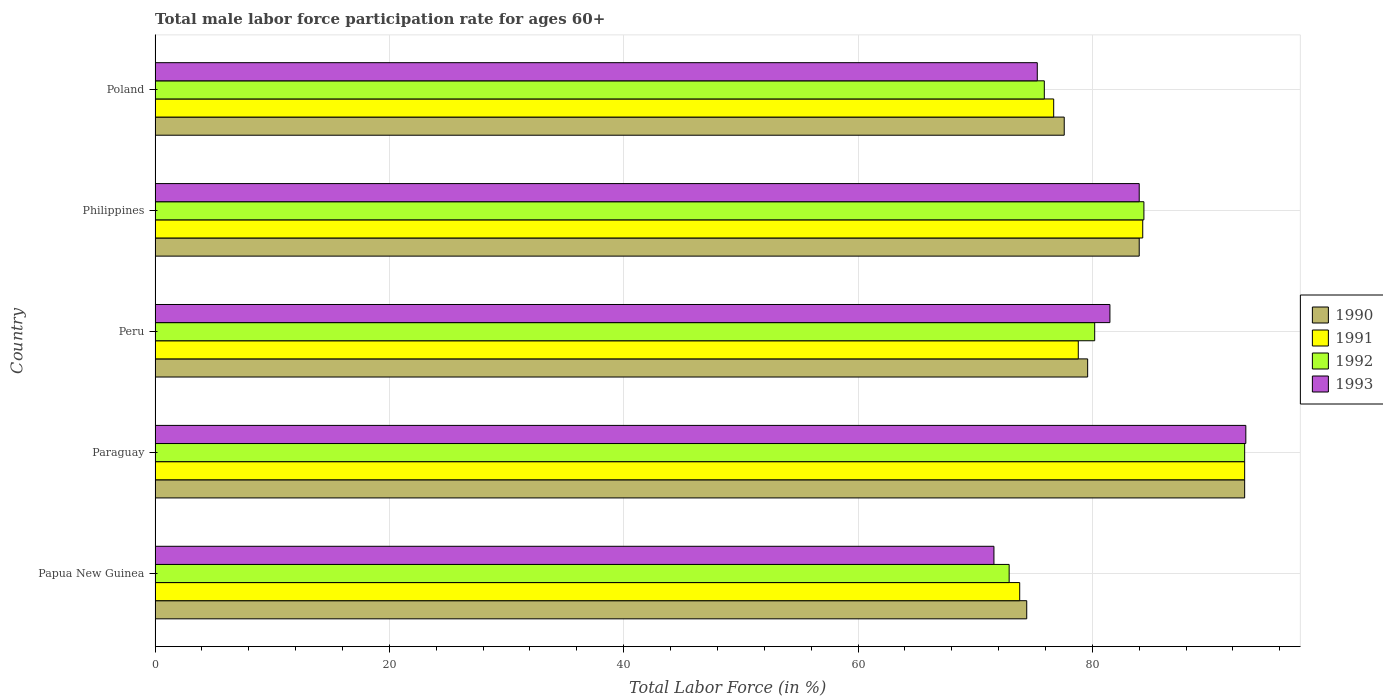How many different coloured bars are there?
Offer a very short reply. 4. Are the number of bars on each tick of the Y-axis equal?
Offer a terse response. Yes. How many bars are there on the 2nd tick from the bottom?
Offer a terse response. 4. What is the male labor force participation rate in 1990 in Philippines?
Your answer should be very brief. 84. Across all countries, what is the maximum male labor force participation rate in 1991?
Your response must be concise. 93. Across all countries, what is the minimum male labor force participation rate in 1993?
Provide a succinct answer. 71.6. In which country was the male labor force participation rate in 1990 maximum?
Your answer should be very brief. Paraguay. In which country was the male labor force participation rate in 1992 minimum?
Your response must be concise. Papua New Guinea. What is the total male labor force participation rate in 1992 in the graph?
Give a very brief answer. 406.4. What is the difference between the male labor force participation rate in 1992 in Paraguay and that in Philippines?
Your answer should be compact. 8.6. What is the difference between the male labor force participation rate in 1992 in Paraguay and the male labor force participation rate in 1990 in Philippines?
Provide a short and direct response. 9. What is the average male labor force participation rate in 1990 per country?
Offer a terse response. 81.72. What is the difference between the male labor force participation rate in 1993 and male labor force participation rate in 1992 in Philippines?
Your response must be concise. -0.4. In how many countries, is the male labor force participation rate in 1991 greater than 80 %?
Offer a very short reply. 2. What is the ratio of the male labor force participation rate in 1992 in Paraguay to that in Philippines?
Make the answer very short. 1.1. Is the male labor force participation rate in 1990 in Papua New Guinea less than that in Poland?
Keep it short and to the point. Yes. What is the difference between the highest and the lowest male labor force participation rate in 1992?
Your answer should be very brief. 20.1. Is the sum of the male labor force participation rate in 1991 in Philippines and Poland greater than the maximum male labor force participation rate in 1993 across all countries?
Offer a very short reply. Yes. Is it the case that in every country, the sum of the male labor force participation rate in 1991 and male labor force participation rate in 1992 is greater than the sum of male labor force participation rate in 1993 and male labor force participation rate in 1990?
Ensure brevity in your answer.  No. What does the 4th bar from the top in Philippines represents?
Offer a terse response. 1990. What does the 4th bar from the bottom in Poland represents?
Offer a terse response. 1993. Is it the case that in every country, the sum of the male labor force participation rate in 1992 and male labor force participation rate in 1990 is greater than the male labor force participation rate in 1991?
Ensure brevity in your answer.  Yes. What is the difference between two consecutive major ticks on the X-axis?
Provide a short and direct response. 20. Does the graph contain grids?
Make the answer very short. Yes. How many legend labels are there?
Ensure brevity in your answer.  4. How are the legend labels stacked?
Your response must be concise. Vertical. What is the title of the graph?
Provide a short and direct response. Total male labor force participation rate for ages 60+. Does "1995" appear as one of the legend labels in the graph?
Provide a short and direct response. No. What is the label or title of the X-axis?
Your answer should be very brief. Total Labor Force (in %). What is the Total Labor Force (in %) in 1990 in Papua New Guinea?
Offer a terse response. 74.4. What is the Total Labor Force (in %) of 1991 in Papua New Guinea?
Your response must be concise. 73.8. What is the Total Labor Force (in %) in 1992 in Papua New Guinea?
Your response must be concise. 72.9. What is the Total Labor Force (in %) in 1993 in Papua New Guinea?
Provide a short and direct response. 71.6. What is the Total Labor Force (in %) of 1990 in Paraguay?
Your answer should be compact. 93. What is the Total Labor Force (in %) in 1991 in Paraguay?
Ensure brevity in your answer.  93. What is the Total Labor Force (in %) in 1992 in Paraguay?
Give a very brief answer. 93. What is the Total Labor Force (in %) in 1993 in Paraguay?
Your answer should be compact. 93.1. What is the Total Labor Force (in %) of 1990 in Peru?
Keep it short and to the point. 79.6. What is the Total Labor Force (in %) of 1991 in Peru?
Keep it short and to the point. 78.8. What is the Total Labor Force (in %) in 1992 in Peru?
Ensure brevity in your answer.  80.2. What is the Total Labor Force (in %) of 1993 in Peru?
Provide a short and direct response. 81.5. What is the Total Labor Force (in %) in 1991 in Philippines?
Keep it short and to the point. 84.3. What is the Total Labor Force (in %) of 1992 in Philippines?
Provide a short and direct response. 84.4. What is the Total Labor Force (in %) in 1993 in Philippines?
Ensure brevity in your answer.  84. What is the Total Labor Force (in %) in 1990 in Poland?
Provide a short and direct response. 77.6. What is the Total Labor Force (in %) in 1991 in Poland?
Provide a succinct answer. 76.7. What is the Total Labor Force (in %) in 1992 in Poland?
Give a very brief answer. 75.9. What is the Total Labor Force (in %) of 1993 in Poland?
Provide a short and direct response. 75.3. Across all countries, what is the maximum Total Labor Force (in %) of 1990?
Keep it short and to the point. 93. Across all countries, what is the maximum Total Labor Force (in %) of 1991?
Your answer should be compact. 93. Across all countries, what is the maximum Total Labor Force (in %) of 1992?
Your answer should be compact. 93. Across all countries, what is the maximum Total Labor Force (in %) in 1993?
Provide a succinct answer. 93.1. Across all countries, what is the minimum Total Labor Force (in %) of 1990?
Your answer should be very brief. 74.4. Across all countries, what is the minimum Total Labor Force (in %) of 1991?
Give a very brief answer. 73.8. Across all countries, what is the minimum Total Labor Force (in %) in 1992?
Your answer should be compact. 72.9. Across all countries, what is the minimum Total Labor Force (in %) in 1993?
Provide a short and direct response. 71.6. What is the total Total Labor Force (in %) in 1990 in the graph?
Your response must be concise. 408.6. What is the total Total Labor Force (in %) in 1991 in the graph?
Keep it short and to the point. 406.6. What is the total Total Labor Force (in %) in 1992 in the graph?
Offer a terse response. 406.4. What is the total Total Labor Force (in %) in 1993 in the graph?
Offer a terse response. 405.5. What is the difference between the Total Labor Force (in %) of 1990 in Papua New Guinea and that in Paraguay?
Offer a very short reply. -18.6. What is the difference between the Total Labor Force (in %) of 1991 in Papua New Guinea and that in Paraguay?
Make the answer very short. -19.2. What is the difference between the Total Labor Force (in %) in 1992 in Papua New Guinea and that in Paraguay?
Provide a succinct answer. -20.1. What is the difference between the Total Labor Force (in %) in 1993 in Papua New Guinea and that in Paraguay?
Offer a very short reply. -21.5. What is the difference between the Total Labor Force (in %) of 1993 in Papua New Guinea and that in Peru?
Make the answer very short. -9.9. What is the difference between the Total Labor Force (in %) in 1991 in Papua New Guinea and that in Philippines?
Offer a very short reply. -10.5. What is the difference between the Total Labor Force (in %) in 1992 in Papua New Guinea and that in Philippines?
Your answer should be very brief. -11.5. What is the difference between the Total Labor Force (in %) in 1993 in Papua New Guinea and that in Philippines?
Keep it short and to the point. -12.4. What is the difference between the Total Labor Force (in %) of 1992 in Papua New Guinea and that in Poland?
Provide a succinct answer. -3. What is the difference between the Total Labor Force (in %) of 1993 in Papua New Guinea and that in Poland?
Offer a terse response. -3.7. What is the difference between the Total Labor Force (in %) of 1990 in Paraguay and that in Peru?
Provide a short and direct response. 13.4. What is the difference between the Total Labor Force (in %) of 1991 in Paraguay and that in Peru?
Provide a succinct answer. 14.2. What is the difference between the Total Labor Force (in %) in 1992 in Paraguay and that in Peru?
Your answer should be compact. 12.8. What is the difference between the Total Labor Force (in %) of 1993 in Paraguay and that in Peru?
Offer a terse response. 11.6. What is the difference between the Total Labor Force (in %) in 1991 in Paraguay and that in Philippines?
Your answer should be very brief. 8.7. What is the difference between the Total Labor Force (in %) in 1990 in Paraguay and that in Poland?
Your answer should be compact. 15.4. What is the difference between the Total Labor Force (in %) of 1992 in Paraguay and that in Poland?
Provide a succinct answer. 17.1. What is the difference between the Total Labor Force (in %) in 1992 in Peru and that in Philippines?
Keep it short and to the point. -4.2. What is the difference between the Total Labor Force (in %) of 1993 in Peru and that in Philippines?
Provide a succinct answer. -2.5. What is the difference between the Total Labor Force (in %) of 1990 in Peru and that in Poland?
Your answer should be compact. 2. What is the difference between the Total Labor Force (in %) in 1990 in Philippines and that in Poland?
Offer a terse response. 6.4. What is the difference between the Total Labor Force (in %) of 1991 in Philippines and that in Poland?
Offer a very short reply. 7.6. What is the difference between the Total Labor Force (in %) in 1990 in Papua New Guinea and the Total Labor Force (in %) in 1991 in Paraguay?
Your answer should be compact. -18.6. What is the difference between the Total Labor Force (in %) of 1990 in Papua New Guinea and the Total Labor Force (in %) of 1992 in Paraguay?
Offer a very short reply. -18.6. What is the difference between the Total Labor Force (in %) in 1990 in Papua New Guinea and the Total Labor Force (in %) in 1993 in Paraguay?
Offer a very short reply. -18.7. What is the difference between the Total Labor Force (in %) in 1991 in Papua New Guinea and the Total Labor Force (in %) in 1992 in Paraguay?
Offer a very short reply. -19.2. What is the difference between the Total Labor Force (in %) in 1991 in Papua New Guinea and the Total Labor Force (in %) in 1993 in Paraguay?
Provide a succinct answer. -19.3. What is the difference between the Total Labor Force (in %) of 1992 in Papua New Guinea and the Total Labor Force (in %) of 1993 in Paraguay?
Offer a terse response. -20.2. What is the difference between the Total Labor Force (in %) in 1990 in Papua New Guinea and the Total Labor Force (in %) in 1993 in Peru?
Your answer should be very brief. -7.1. What is the difference between the Total Labor Force (in %) in 1991 in Papua New Guinea and the Total Labor Force (in %) in 1992 in Peru?
Your response must be concise. -6.4. What is the difference between the Total Labor Force (in %) in 1992 in Papua New Guinea and the Total Labor Force (in %) in 1993 in Peru?
Make the answer very short. -8.6. What is the difference between the Total Labor Force (in %) in 1990 in Papua New Guinea and the Total Labor Force (in %) in 1991 in Philippines?
Provide a succinct answer. -9.9. What is the difference between the Total Labor Force (in %) in 1990 in Papua New Guinea and the Total Labor Force (in %) in 1992 in Philippines?
Your answer should be compact. -10. What is the difference between the Total Labor Force (in %) of 1991 in Papua New Guinea and the Total Labor Force (in %) of 1992 in Philippines?
Keep it short and to the point. -10.6. What is the difference between the Total Labor Force (in %) of 1991 in Papua New Guinea and the Total Labor Force (in %) of 1993 in Philippines?
Your answer should be compact. -10.2. What is the difference between the Total Labor Force (in %) of 1992 in Papua New Guinea and the Total Labor Force (in %) of 1993 in Philippines?
Ensure brevity in your answer.  -11.1. What is the difference between the Total Labor Force (in %) in 1990 in Papua New Guinea and the Total Labor Force (in %) in 1991 in Poland?
Provide a short and direct response. -2.3. What is the difference between the Total Labor Force (in %) in 1990 in Papua New Guinea and the Total Labor Force (in %) in 1992 in Poland?
Your answer should be compact. -1.5. What is the difference between the Total Labor Force (in %) of 1991 in Papua New Guinea and the Total Labor Force (in %) of 1992 in Poland?
Provide a short and direct response. -2.1. What is the difference between the Total Labor Force (in %) in 1991 in Papua New Guinea and the Total Labor Force (in %) in 1993 in Poland?
Give a very brief answer. -1.5. What is the difference between the Total Labor Force (in %) of 1990 in Paraguay and the Total Labor Force (in %) of 1991 in Peru?
Offer a very short reply. 14.2. What is the difference between the Total Labor Force (in %) of 1991 in Paraguay and the Total Labor Force (in %) of 1993 in Peru?
Make the answer very short. 11.5. What is the difference between the Total Labor Force (in %) of 1992 in Paraguay and the Total Labor Force (in %) of 1993 in Peru?
Give a very brief answer. 11.5. What is the difference between the Total Labor Force (in %) in 1990 in Paraguay and the Total Labor Force (in %) in 1991 in Philippines?
Your answer should be very brief. 8.7. What is the difference between the Total Labor Force (in %) of 1990 in Paraguay and the Total Labor Force (in %) of 1993 in Philippines?
Your response must be concise. 9. What is the difference between the Total Labor Force (in %) of 1991 in Paraguay and the Total Labor Force (in %) of 1993 in Poland?
Provide a short and direct response. 17.7. What is the difference between the Total Labor Force (in %) in 1992 in Paraguay and the Total Labor Force (in %) in 1993 in Poland?
Give a very brief answer. 17.7. What is the difference between the Total Labor Force (in %) in 1990 in Peru and the Total Labor Force (in %) in 1991 in Philippines?
Offer a terse response. -4.7. What is the difference between the Total Labor Force (in %) in 1990 in Peru and the Total Labor Force (in %) in 1993 in Philippines?
Your answer should be compact. -4.4. What is the difference between the Total Labor Force (in %) of 1991 in Peru and the Total Labor Force (in %) of 1993 in Philippines?
Make the answer very short. -5.2. What is the difference between the Total Labor Force (in %) in 1990 in Peru and the Total Labor Force (in %) in 1991 in Poland?
Offer a very short reply. 2.9. What is the difference between the Total Labor Force (in %) in 1990 in Peru and the Total Labor Force (in %) in 1993 in Poland?
Ensure brevity in your answer.  4.3. What is the difference between the Total Labor Force (in %) in 1991 in Peru and the Total Labor Force (in %) in 1992 in Poland?
Keep it short and to the point. 2.9. What is the difference between the Total Labor Force (in %) of 1990 in Philippines and the Total Labor Force (in %) of 1991 in Poland?
Offer a terse response. 7.3. What is the difference between the Total Labor Force (in %) in 1990 in Philippines and the Total Labor Force (in %) in 1992 in Poland?
Your response must be concise. 8.1. What is the difference between the Total Labor Force (in %) of 1990 in Philippines and the Total Labor Force (in %) of 1993 in Poland?
Make the answer very short. 8.7. What is the difference between the Total Labor Force (in %) of 1991 in Philippines and the Total Labor Force (in %) of 1992 in Poland?
Provide a succinct answer. 8.4. What is the average Total Labor Force (in %) of 1990 per country?
Give a very brief answer. 81.72. What is the average Total Labor Force (in %) in 1991 per country?
Provide a short and direct response. 81.32. What is the average Total Labor Force (in %) of 1992 per country?
Make the answer very short. 81.28. What is the average Total Labor Force (in %) in 1993 per country?
Offer a terse response. 81.1. What is the difference between the Total Labor Force (in %) of 1990 and Total Labor Force (in %) of 1991 in Papua New Guinea?
Your answer should be compact. 0.6. What is the difference between the Total Labor Force (in %) of 1991 and Total Labor Force (in %) of 1992 in Papua New Guinea?
Offer a very short reply. 0.9. What is the difference between the Total Labor Force (in %) in 1992 and Total Labor Force (in %) in 1993 in Papua New Guinea?
Your response must be concise. 1.3. What is the difference between the Total Labor Force (in %) in 1990 and Total Labor Force (in %) in 1992 in Paraguay?
Offer a terse response. 0. What is the difference between the Total Labor Force (in %) in 1990 and Total Labor Force (in %) in 1993 in Paraguay?
Ensure brevity in your answer.  -0.1. What is the difference between the Total Labor Force (in %) of 1991 and Total Labor Force (in %) of 1992 in Paraguay?
Offer a terse response. 0. What is the difference between the Total Labor Force (in %) in 1991 and Total Labor Force (in %) in 1992 in Peru?
Ensure brevity in your answer.  -1.4. What is the difference between the Total Labor Force (in %) of 1991 and Total Labor Force (in %) of 1993 in Peru?
Your response must be concise. -2.7. What is the difference between the Total Labor Force (in %) of 1990 and Total Labor Force (in %) of 1991 in Philippines?
Ensure brevity in your answer.  -0.3. What is the difference between the Total Labor Force (in %) in 1990 and Total Labor Force (in %) in 1992 in Philippines?
Make the answer very short. -0.4. What is the difference between the Total Labor Force (in %) of 1990 and Total Labor Force (in %) of 1993 in Philippines?
Provide a succinct answer. 0. What is the difference between the Total Labor Force (in %) in 1991 and Total Labor Force (in %) in 1992 in Philippines?
Offer a very short reply. -0.1. What is the difference between the Total Labor Force (in %) of 1990 and Total Labor Force (in %) of 1991 in Poland?
Provide a succinct answer. 0.9. What is the difference between the Total Labor Force (in %) in 1990 and Total Labor Force (in %) in 1993 in Poland?
Make the answer very short. 2.3. What is the difference between the Total Labor Force (in %) of 1991 and Total Labor Force (in %) of 1992 in Poland?
Your response must be concise. 0.8. What is the difference between the Total Labor Force (in %) in 1991 and Total Labor Force (in %) in 1993 in Poland?
Provide a succinct answer. 1.4. What is the ratio of the Total Labor Force (in %) in 1990 in Papua New Guinea to that in Paraguay?
Make the answer very short. 0.8. What is the ratio of the Total Labor Force (in %) in 1991 in Papua New Guinea to that in Paraguay?
Keep it short and to the point. 0.79. What is the ratio of the Total Labor Force (in %) in 1992 in Papua New Guinea to that in Paraguay?
Your response must be concise. 0.78. What is the ratio of the Total Labor Force (in %) of 1993 in Papua New Guinea to that in Paraguay?
Give a very brief answer. 0.77. What is the ratio of the Total Labor Force (in %) of 1990 in Papua New Guinea to that in Peru?
Keep it short and to the point. 0.93. What is the ratio of the Total Labor Force (in %) of 1991 in Papua New Guinea to that in Peru?
Offer a terse response. 0.94. What is the ratio of the Total Labor Force (in %) of 1992 in Papua New Guinea to that in Peru?
Make the answer very short. 0.91. What is the ratio of the Total Labor Force (in %) in 1993 in Papua New Guinea to that in Peru?
Your response must be concise. 0.88. What is the ratio of the Total Labor Force (in %) of 1990 in Papua New Guinea to that in Philippines?
Your response must be concise. 0.89. What is the ratio of the Total Labor Force (in %) in 1991 in Papua New Guinea to that in Philippines?
Your response must be concise. 0.88. What is the ratio of the Total Labor Force (in %) in 1992 in Papua New Guinea to that in Philippines?
Ensure brevity in your answer.  0.86. What is the ratio of the Total Labor Force (in %) in 1993 in Papua New Guinea to that in Philippines?
Make the answer very short. 0.85. What is the ratio of the Total Labor Force (in %) in 1990 in Papua New Guinea to that in Poland?
Your answer should be very brief. 0.96. What is the ratio of the Total Labor Force (in %) in 1991 in Papua New Guinea to that in Poland?
Keep it short and to the point. 0.96. What is the ratio of the Total Labor Force (in %) of 1992 in Papua New Guinea to that in Poland?
Ensure brevity in your answer.  0.96. What is the ratio of the Total Labor Force (in %) of 1993 in Papua New Guinea to that in Poland?
Ensure brevity in your answer.  0.95. What is the ratio of the Total Labor Force (in %) of 1990 in Paraguay to that in Peru?
Offer a very short reply. 1.17. What is the ratio of the Total Labor Force (in %) of 1991 in Paraguay to that in Peru?
Ensure brevity in your answer.  1.18. What is the ratio of the Total Labor Force (in %) of 1992 in Paraguay to that in Peru?
Provide a short and direct response. 1.16. What is the ratio of the Total Labor Force (in %) of 1993 in Paraguay to that in Peru?
Offer a terse response. 1.14. What is the ratio of the Total Labor Force (in %) of 1990 in Paraguay to that in Philippines?
Ensure brevity in your answer.  1.11. What is the ratio of the Total Labor Force (in %) of 1991 in Paraguay to that in Philippines?
Your answer should be compact. 1.1. What is the ratio of the Total Labor Force (in %) in 1992 in Paraguay to that in Philippines?
Offer a terse response. 1.1. What is the ratio of the Total Labor Force (in %) of 1993 in Paraguay to that in Philippines?
Your answer should be very brief. 1.11. What is the ratio of the Total Labor Force (in %) of 1990 in Paraguay to that in Poland?
Offer a terse response. 1.2. What is the ratio of the Total Labor Force (in %) in 1991 in Paraguay to that in Poland?
Give a very brief answer. 1.21. What is the ratio of the Total Labor Force (in %) of 1992 in Paraguay to that in Poland?
Make the answer very short. 1.23. What is the ratio of the Total Labor Force (in %) of 1993 in Paraguay to that in Poland?
Provide a short and direct response. 1.24. What is the ratio of the Total Labor Force (in %) in 1990 in Peru to that in Philippines?
Provide a short and direct response. 0.95. What is the ratio of the Total Labor Force (in %) of 1991 in Peru to that in Philippines?
Ensure brevity in your answer.  0.93. What is the ratio of the Total Labor Force (in %) of 1992 in Peru to that in Philippines?
Offer a terse response. 0.95. What is the ratio of the Total Labor Force (in %) of 1993 in Peru to that in Philippines?
Your answer should be very brief. 0.97. What is the ratio of the Total Labor Force (in %) of 1990 in Peru to that in Poland?
Give a very brief answer. 1.03. What is the ratio of the Total Labor Force (in %) in 1991 in Peru to that in Poland?
Ensure brevity in your answer.  1.03. What is the ratio of the Total Labor Force (in %) of 1992 in Peru to that in Poland?
Your response must be concise. 1.06. What is the ratio of the Total Labor Force (in %) in 1993 in Peru to that in Poland?
Make the answer very short. 1.08. What is the ratio of the Total Labor Force (in %) in 1990 in Philippines to that in Poland?
Provide a succinct answer. 1.08. What is the ratio of the Total Labor Force (in %) of 1991 in Philippines to that in Poland?
Make the answer very short. 1.1. What is the ratio of the Total Labor Force (in %) of 1992 in Philippines to that in Poland?
Offer a very short reply. 1.11. What is the ratio of the Total Labor Force (in %) in 1993 in Philippines to that in Poland?
Provide a short and direct response. 1.12. What is the difference between the highest and the second highest Total Labor Force (in %) in 1990?
Offer a very short reply. 9. What is the difference between the highest and the second highest Total Labor Force (in %) of 1991?
Provide a short and direct response. 8.7. What is the difference between the highest and the second highest Total Labor Force (in %) of 1992?
Offer a terse response. 8.6. What is the difference between the highest and the second highest Total Labor Force (in %) in 1993?
Your answer should be very brief. 9.1. What is the difference between the highest and the lowest Total Labor Force (in %) of 1990?
Provide a succinct answer. 18.6. What is the difference between the highest and the lowest Total Labor Force (in %) of 1991?
Keep it short and to the point. 19.2. What is the difference between the highest and the lowest Total Labor Force (in %) in 1992?
Offer a terse response. 20.1. What is the difference between the highest and the lowest Total Labor Force (in %) of 1993?
Provide a short and direct response. 21.5. 